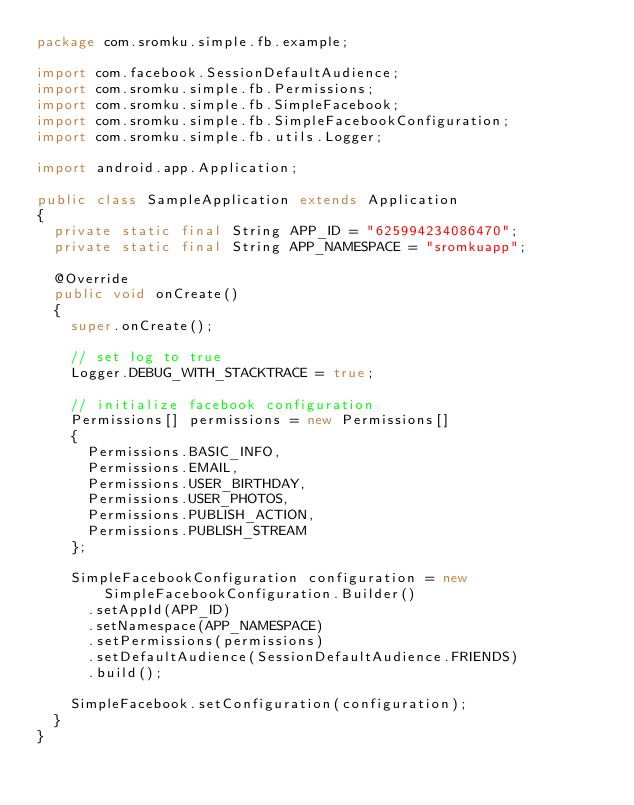Convert code to text. <code><loc_0><loc_0><loc_500><loc_500><_Java_>package com.sromku.simple.fb.example;

import com.facebook.SessionDefaultAudience;
import com.sromku.simple.fb.Permissions;
import com.sromku.simple.fb.SimpleFacebook;
import com.sromku.simple.fb.SimpleFacebookConfiguration;
import com.sromku.simple.fb.utils.Logger;

import android.app.Application;

public class SampleApplication extends Application
{
	private static final String APP_ID = "625994234086470";
	private static final String APP_NAMESPACE = "sromkuapp";
	
	@Override
	public void onCreate()
	{
		super.onCreate();
		
		// set log to true
		Logger.DEBUG_WITH_STACKTRACE = true;

		// initialize facebook configuration
		Permissions[] permissions = new Permissions[]
		{
			Permissions.BASIC_INFO,
			Permissions.EMAIL,
			Permissions.USER_BIRTHDAY,
			Permissions.USER_PHOTOS,
			Permissions.PUBLISH_ACTION,
			Permissions.PUBLISH_STREAM
		};

		SimpleFacebookConfiguration configuration = new SimpleFacebookConfiguration.Builder()
			.setAppId(APP_ID)
			.setNamespace(APP_NAMESPACE)
			.setPermissions(permissions)
			.setDefaultAudience(SessionDefaultAudience.FRIENDS)
			.build();

		SimpleFacebook.setConfiguration(configuration);
	}
}
</code> 